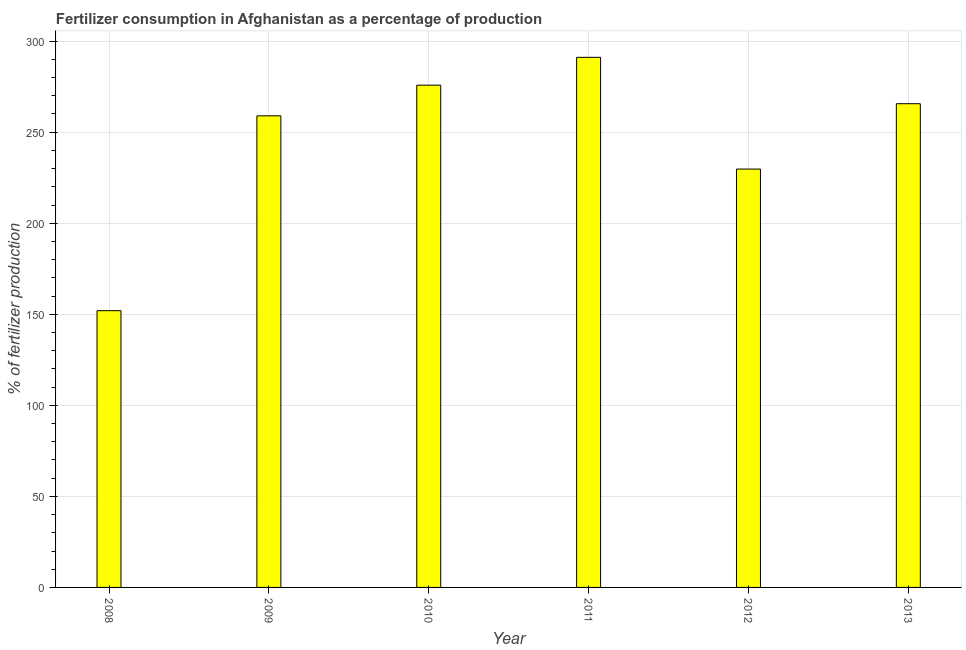Does the graph contain any zero values?
Make the answer very short. No. Does the graph contain grids?
Ensure brevity in your answer.  Yes. What is the title of the graph?
Offer a terse response. Fertilizer consumption in Afghanistan as a percentage of production. What is the label or title of the X-axis?
Keep it short and to the point. Year. What is the label or title of the Y-axis?
Keep it short and to the point. % of fertilizer production. What is the amount of fertilizer consumption in 2011?
Keep it short and to the point. 291.11. Across all years, what is the maximum amount of fertilizer consumption?
Your answer should be very brief. 291.11. Across all years, what is the minimum amount of fertilizer consumption?
Your answer should be very brief. 151.98. In which year was the amount of fertilizer consumption minimum?
Your response must be concise. 2008. What is the sum of the amount of fertilizer consumption?
Make the answer very short. 1473.26. What is the difference between the amount of fertilizer consumption in 2008 and 2009?
Offer a terse response. -107. What is the average amount of fertilizer consumption per year?
Your answer should be very brief. 245.54. What is the median amount of fertilizer consumption?
Offer a terse response. 262.3. In how many years, is the amount of fertilizer consumption greater than 190 %?
Your response must be concise. 5. Do a majority of the years between 2009 and 2012 (inclusive) have amount of fertilizer consumption greater than 250 %?
Give a very brief answer. Yes. What is the ratio of the amount of fertilizer consumption in 2010 to that in 2013?
Provide a succinct answer. 1.04. Is the amount of fertilizer consumption in 2012 less than that in 2013?
Ensure brevity in your answer.  Yes. What is the difference between the highest and the second highest amount of fertilizer consumption?
Your response must be concise. 15.29. What is the difference between the highest and the lowest amount of fertilizer consumption?
Make the answer very short. 139.13. How many bars are there?
Your answer should be compact. 6. What is the difference between two consecutive major ticks on the Y-axis?
Offer a terse response. 50. What is the % of fertilizer production of 2008?
Your answer should be very brief. 151.98. What is the % of fertilizer production in 2009?
Your answer should be compact. 258.97. What is the % of fertilizer production of 2010?
Offer a very short reply. 275.82. What is the % of fertilizer production in 2011?
Offer a very short reply. 291.11. What is the % of fertilizer production in 2012?
Ensure brevity in your answer.  229.74. What is the % of fertilizer production of 2013?
Provide a short and direct response. 265.63. What is the difference between the % of fertilizer production in 2008 and 2009?
Offer a terse response. -107. What is the difference between the % of fertilizer production in 2008 and 2010?
Keep it short and to the point. -123.84. What is the difference between the % of fertilizer production in 2008 and 2011?
Keep it short and to the point. -139.13. What is the difference between the % of fertilizer production in 2008 and 2012?
Your answer should be very brief. -77.77. What is the difference between the % of fertilizer production in 2008 and 2013?
Your answer should be compact. -113.66. What is the difference between the % of fertilizer production in 2009 and 2010?
Provide a short and direct response. -16.85. What is the difference between the % of fertilizer production in 2009 and 2011?
Your answer should be compact. -32.13. What is the difference between the % of fertilizer production in 2009 and 2012?
Keep it short and to the point. 29.23. What is the difference between the % of fertilizer production in 2009 and 2013?
Make the answer very short. -6.66. What is the difference between the % of fertilizer production in 2010 and 2011?
Offer a very short reply. -15.29. What is the difference between the % of fertilizer production in 2010 and 2012?
Keep it short and to the point. 46.07. What is the difference between the % of fertilizer production in 2010 and 2013?
Provide a short and direct response. 10.18. What is the difference between the % of fertilizer production in 2011 and 2012?
Your response must be concise. 61.36. What is the difference between the % of fertilizer production in 2011 and 2013?
Your answer should be compact. 25.47. What is the difference between the % of fertilizer production in 2012 and 2013?
Your answer should be very brief. -35.89. What is the ratio of the % of fertilizer production in 2008 to that in 2009?
Offer a very short reply. 0.59. What is the ratio of the % of fertilizer production in 2008 to that in 2010?
Your answer should be compact. 0.55. What is the ratio of the % of fertilizer production in 2008 to that in 2011?
Your response must be concise. 0.52. What is the ratio of the % of fertilizer production in 2008 to that in 2012?
Offer a terse response. 0.66. What is the ratio of the % of fertilizer production in 2008 to that in 2013?
Provide a succinct answer. 0.57. What is the ratio of the % of fertilizer production in 2009 to that in 2010?
Make the answer very short. 0.94. What is the ratio of the % of fertilizer production in 2009 to that in 2011?
Keep it short and to the point. 0.89. What is the ratio of the % of fertilizer production in 2009 to that in 2012?
Provide a succinct answer. 1.13. What is the ratio of the % of fertilizer production in 2010 to that in 2011?
Your response must be concise. 0.95. What is the ratio of the % of fertilizer production in 2010 to that in 2012?
Make the answer very short. 1.2. What is the ratio of the % of fertilizer production in 2010 to that in 2013?
Provide a short and direct response. 1.04. What is the ratio of the % of fertilizer production in 2011 to that in 2012?
Your answer should be very brief. 1.27. What is the ratio of the % of fertilizer production in 2011 to that in 2013?
Keep it short and to the point. 1.1. What is the ratio of the % of fertilizer production in 2012 to that in 2013?
Make the answer very short. 0.86. 